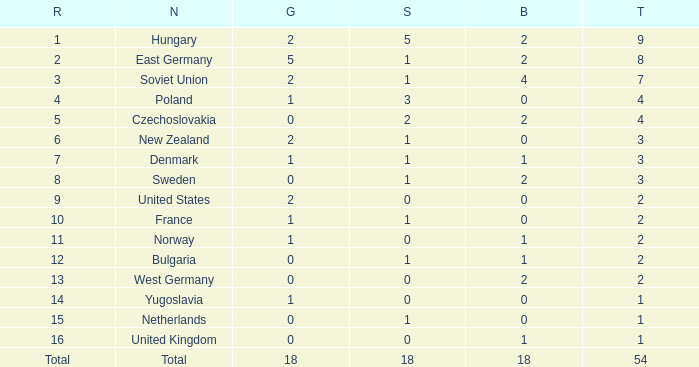What is the lowest total for those receiving less than 18 but more than 14? 1.0. 